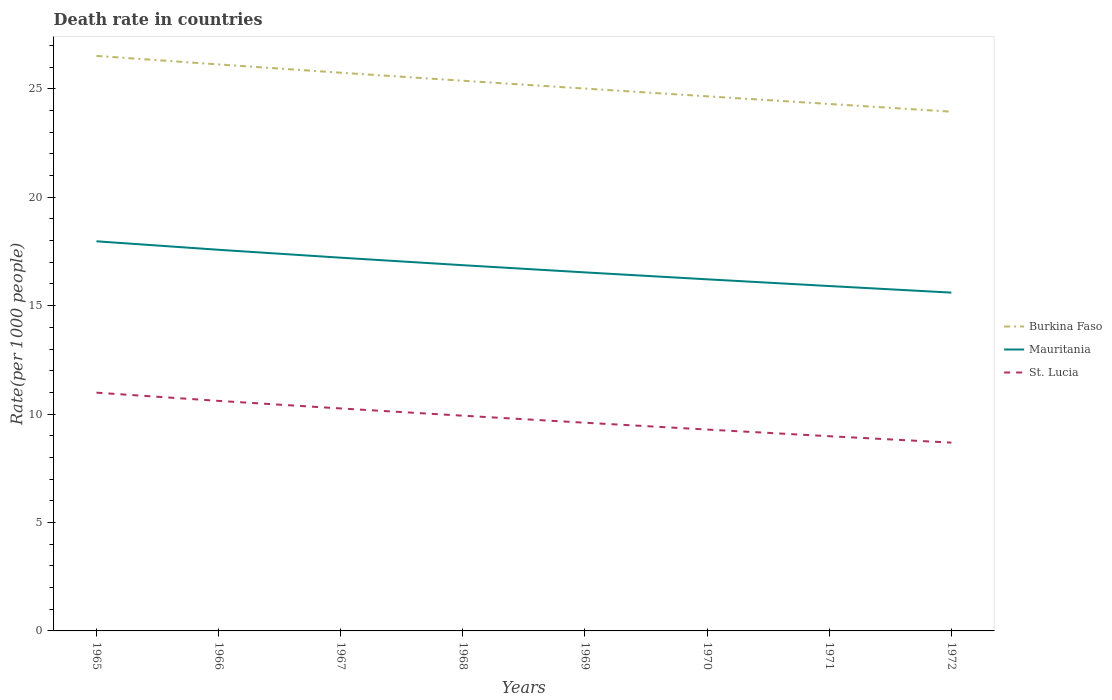Does the line corresponding to Burkina Faso intersect with the line corresponding to St. Lucia?
Keep it short and to the point. No. Across all years, what is the maximum death rate in Mauritania?
Provide a short and direct response. 15.6. In which year was the death rate in St. Lucia maximum?
Your answer should be compact. 1972. What is the total death rate in St. Lucia in the graph?
Offer a terse response. 0.32. What is the difference between the highest and the second highest death rate in Burkina Faso?
Your answer should be compact. 2.57. What is the difference between the highest and the lowest death rate in St. Lucia?
Make the answer very short. 4. Is the death rate in Burkina Faso strictly greater than the death rate in Mauritania over the years?
Offer a terse response. No. How many lines are there?
Your response must be concise. 3. Are the values on the major ticks of Y-axis written in scientific E-notation?
Provide a short and direct response. No. Does the graph contain any zero values?
Your answer should be compact. No. Where does the legend appear in the graph?
Offer a very short reply. Center right. What is the title of the graph?
Offer a very short reply. Death rate in countries. Does "Korea (Democratic)" appear as one of the legend labels in the graph?
Your answer should be compact. No. What is the label or title of the X-axis?
Your answer should be very brief. Years. What is the label or title of the Y-axis?
Ensure brevity in your answer.  Rate(per 1000 people). What is the Rate(per 1000 people) of Burkina Faso in 1965?
Offer a terse response. 26.52. What is the Rate(per 1000 people) in Mauritania in 1965?
Make the answer very short. 17.97. What is the Rate(per 1000 people) in St. Lucia in 1965?
Make the answer very short. 10.99. What is the Rate(per 1000 people) of Burkina Faso in 1966?
Ensure brevity in your answer.  26.12. What is the Rate(per 1000 people) of Mauritania in 1966?
Your answer should be very brief. 17.58. What is the Rate(per 1000 people) of St. Lucia in 1966?
Offer a very short reply. 10.61. What is the Rate(per 1000 people) of Burkina Faso in 1967?
Ensure brevity in your answer.  25.74. What is the Rate(per 1000 people) of Mauritania in 1967?
Keep it short and to the point. 17.21. What is the Rate(per 1000 people) of St. Lucia in 1967?
Offer a very short reply. 10.26. What is the Rate(per 1000 people) in Burkina Faso in 1968?
Your answer should be very brief. 25.37. What is the Rate(per 1000 people) of Mauritania in 1968?
Ensure brevity in your answer.  16.86. What is the Rate(per 1000 people) in St. Lucia in 1968?
Offer a terse response. 9.93. What is the Rate(per 1000 people) in Burkina Faso in 1969?
Ensure brevity in your answer.  25.01. What is the Rate(per 1000 people) in Mauritania in 1969?
Make the answer very short. 16.53. What is the Rate(per 1000 people) of St. Lucia in 1969?
Your answer should be very brief. 9.6. What is the Rate(per 1000 people) in Burkina Faso in 1970?
Ensure brevity in your answer.  24.65. What is the Rate(per 1000 people) of Mauritania in 1970?
Give a very brief answer. 16.21. What is the Rate(per 1000 people) in St. Lucia in 1970?
Your answer should be compact. 9.29. What is the Rate(per 1000 people) in Burkina Faso in 1971?
Provide a succinct answer. 24.3. What is the Rate(per 1000 people) of Mauritania in 1971?
Offer a terse response. 15.9. What is the Rate(per 1000 people) of St. Lucia in 1971?
Ensure brevity in your answer.  8.98. What is the Rate(per 1000 people) of Burkina Faso in 1972?
Keep it short and to the point. 23.94. What is the Rate(per 1000 people) in Mauritania in 1972?
Provide a short and direct response. 15.6. What is the Rate(per 1000 people) in St. Lucia in 1972?
Provide a short and direct response. 8.68. Across all years, what is the maximum Rate(per 1000 people) in Burkina Faso?
Your answer should be compact. 26.52. Across all years, what is the maximum Rate(per 1000 people) in Mauritania?
Offer a terse response. 17.97. Across all years, what is the maximum Rate(per 1000 people) in St. Lucia?
Give a very brief answer. 10.99. Across all years, what is the minimum Rate(per 1000 people) of Burkina Faso?
Give a very brief answer. 23.94. Across all years, what is the minimum Rate(per 1000 people) of Mauritania?
Your response must be concise. 15.6. Across all years, what is the minimum Rate(per 1000 people) of St. Lucia?
Provide a short and direct response. 8.68. What is the total Rate(per 1000 people) in Burkina Faso in the graph?
Provide a short and direct response. 201.66. What is the total Rate(per 1000 people) of Mauritania in the graph?
Make the answer very short. 133.87. What is the total Rate(per 1000 people) in St. Lucia in the graph?
Provide a succinct answer. 78.33. What is the difference between the Rate(per 1000 people) in Burkina Faso in 1965 and that in 1966?
Give a very brief answer. 0.39. What is the difference between the Rate(per 1000 people) in Mauritania in 1965 and that in 1966?
Provide a short and direct response. 0.39. What is the difference between the Rate(per 1000 people) in St. Lucia in 1965 and that in 1966?
Offer a very short reply. 0.38. What is the difference between the Rate(per 1000 people) in Burkina Faso in 1965 and that in 1967?
Give a very brief answer. 0.78. What is the difference between the Rate(per 1000 people) in Mauritania in 1965 and that in 1967?
Ensure brevity in your answer.  0.76. What is the difference between the Rate(per 1000 people) of St. Lucia in 1965 and that in 1967?
Make the answer very short. 0.73. What is the difference between the Rate(per 1000 people) in Burkina Faso in 1965 and that in 1968?
Provide a short and direct response. 1.15. What is the difference between the Rate(per 1000 people) of Mauritania in 1965 and that in 1968?
Provide a short and direct response. 1.1. What is the difference between the Rate(per 1000 people) in St. Lucia in 1965 and that in 1968?
Your response must be concise. 1.06. What is the difference between the Rate(per 1000 people) in Burkina Faso in 1965 and that in 1969?
Your response must be concise. 1.51. What is the difference between the Rate(per 1000 people) in Mauritania in 1965 and that in 1969?
Offer a very short reply. 1.43. What is the difference between the Rate(per 1000 people) of St. Lucia in 1965 and that in 1969?
Your answer should be compact. 1.39. What is the difference between the Rate(per 1000 people) in Burkina Faso in 1965 and that in 1970?
Offer a terse response. 1.86. What is the difference between the Rate(per 1000 people) in Mauritania in 1965 and that in 1970?
Provide a short and direct response. 1.75. What is the difference between the Rate(per 1000 people) in St. Lucia in 1965 and that in 1970?
Keep it short and to the point. 1.7. What is the difference between the Rate(per 1000 people) of Burkina Faso in 1965 and that in 1971?
Offer a terse response. 2.22. What is the difference between the Rate(per 1000 people) of Mauritania in 1965 and that in 1971?
Offer a very short reply. 2.06. What is the difference between the Rate(per 1000 people) of St. Lucia in 1965 and that in 1971?
Offer a terse response. 2.01. What is the difference between the Rate(per 1000 people) in Burkina Faso in 1965 and that in 1972?
Keep it short and to the point. 2.57. What is the difference between the Rate(per 1000 people) in Mauritania in 1965 and that in 1972?
Keep it short and to the point. 2.37. What is the difference between the Rate(per 1000 people) of St. Lucia in 1965 and that in 1972?
Provide a short and direct response. 2.3. What is the difference between the Rate(per 1000 people) of Burkina Faso in 1966 and that in 1967?
Your answer should be compact. 0.38. What is the difference between the Rate(per 1000 people) in Mauritania in 1966 and that in 1967?
Ensure brevity in your answer.  0.36. What is the difference between the Rate(per 1000 people) in St. Lucia in 1966 and that in 1967?
Offer a terse response. 0.35. What is the difference between the Rate(per 1000 people) of Burkina Faso in 1966 and that in 1968?
Give a very brief answer. 0.75. What is the difference between the Rate(per 1000 people) of Mauritania in 1966 and that in 1968?
Your answer should be very brief. 0.71. What is the difference between the Rate(per 1000 people) of St. Lucia in 1966 and that in 1968?
Make the answer very short. 0.68. What is the difference between the Rate(per 1000 people) in Burkina Faso in 1966 and that in 1969?
Give a very brief answer. 1.11. What is the difference between the Rate(per 1000 people) in Mauritania in 1966 and that in 1969?
Keep it short and to the point. 1.04. What is the difference between the Rate(per 1000 people) in St. Lucia in 1966 and that in 1969?
Your response must be concise. 1.01. What is the difference between the Rate(per 1000 people) in Burkina Faso in 1966 and that in 1970?
Provide a succinct answer. 1.47. What is the difference between the Rate(per 1000 people) in Mauritania in 1966 and that in 1970?
Make the answer very short. 1.36. What is the difference between the Rate(per 1000 people) of St. Lucia in 1966 and that in 1970?
Give a very brief answer. 1.32. What is the difference between the Rate(per 1000 people) in Burkina Faso in 1966 and that in 1971?
Your answer should be very brief. 1.82. What is the difference between the Rate(per 1000 people) in Mauritania in 1966 and that in 1971?
Your answer should be very brief. 1.67. What is the difference between the Rate(per 1000 people) in St. Lucia in 1966 and that in 1971?
Your answer should be very brief. 1.63. What is the difference between the Rate(per 1000 people) in Burkina Faso in 1966 and that in 1972?
Keep it short and to the point. 2.18. What is the difference between the Rate(per 1000 people) in Mauritania in 1966 and that in 1972?
Keep it short and to the point. 1.98. What is the difference between the Rate(per 1000 people) of St. Lucia in 1966 and that in 1972?
Your response must be concise. 1.93. What is the difference between the Rate(per 1000 people) of Burkina Faso in 1967 and that in 1968?
Give a very brief answer. 0.37. What is the difference between the Rate(per 1000 people) in Mauritania in 1967 and that in 1968?
Your response must be concise. 0.35. What is the difference between the Rate(per 1000 people) of St. Lucia in 1967 and that in 1968?
Give a very brief answer. 0.33. What is the difference between the Rate(per 1000 people) in Burkina Faso in 1967 and that in 1969?
Make the answer very short. 0.73. What is the difference between the Rate(per 1000 people) in Mauritania in 1967 and that in 1969?
Provide a short and direct response. 0.68. What is the difference between the Rate(per 1000 people) of St. Lucia in 1967 and that in 1969?
Offer a terse response. 0.66. What is the difference between the Rate(per 1000 people) of Burkina Faso in 1967 and that in 1970?
Give a very brief answer. 1.09. What is the difference between the Rate(per 1000 people) in Mauritania in 1967 and that in 1970?
Ensure brevity in your answer.  1. What is the difference between the Rate(per 1000 people) in St. Lucia in 1967 and that in 1970?
Your response must be concise. 0.97. What is the difference between the Rate(per 1000 people) of Burkina Faso in 1967 and that in 1971?
Your answer should be very brief. 1.44. What is the difference between the Rate(per 1000 people) of Mauritania in 1967 and that in 1971?
Your answer should be very brief. 1.31. What is the difference between the Rate(per 1000 people) of St. Lucia in 1967 and that in 1971?
Provide a short and direct response. 1.28. What is the difference between the Rate(per 1000 people) in Burkina Faso in 1967 and that in 1972?
Your answer should be very brief. 1.8. What is the difference between the Rate(per 1000 people) in Mauritania in 1967 and that in 1972?
Provide a short and direct response. 1.61. What is the difference between the Rate(per 1000 people) of St. Lucia in 1967 and that in 1972?
Provide a succinct answer. 1.58. What is the difference between the Rate(per 1000 people) in Burkina Faso in 1968 and that in 1969?
Provide a succinct answer. 0.36. What is the difference between the Rate(per 1000 people) in Mauritania in 1968 and that in 1969?
Offer a terse response. 0.33. What is the difference between the Rate(per 1000 people) of St. Lucia in 1968 and that in 1969?
Keep it short and to the point. 0.32. What is the difference between the Rate(per 1000 people) of Burkina Faso in 1968 and that in 1970?
Provide a succinct answer. 0.72. What is the difference between the Rate(per 1000 people) of Mauritania in 1968 and that in 1970?
Keep it short and to the point. 0.65. What is the difference between the Rate(per 1000 people) in St. Lucia in 1968 and that in 1970?
Offer a very short reply. 0.64. What is the difference between the Rate(per 1000 people) of Burkina Faso in 1968 and that in 1971?
Your answer should be compact. 1.07. What is the difference between the Rate(per 1000 people) in Mauritania in 1968 and that in 1971?
Offer a very short reply. 0.96. What is the difference between the Rate(per 1000 people) in St. Lucia in 1968 and that in 1971?
Provide a succinct answer. 0.95. What is the difference between the Rate(per 1000 people) of Burkina Faso in 1968 and that in 1972?
Provide a succinct answer. 1.43. What is the difference between the Rate(per 1000 people) in Mauritania in 1968 and that in 1972?
Offer a very short reply. 1.26. What is the difference between the Rate(per 1000 people) of St. Lucia in 1968 and that in 1972?
Make the answer very short. 1.24. What is the difference between the Rate(per 1000 people) in Burkina Faso in 1969 and that in 1970?
Offer a terse response. 0.36. What is the difference between the Rate(per 1000 people) of Mauritania in 1969 and that in 1970?
Make the answer very short. 0.32. What is the difference between the Rate(per 1000 people) of St. Lucia in 1969 and that in 1970?
Offer a very short reply. 0.32. What is the difference between the Rate(per 1000 people) of Burkina Faso in 1969 and that in 1971?
Make the answer very short. 0.71. What is the difference between the Rate(per 1000 people) of Mauritania in 1969 and that in 1971?
Make the answer very short. 0.63. What is the difference between the Rate(per 1000 people) in St. Lucia in 1969 and that in 1971?
Your answer should be very brief. 0.62. What is the difference between the Rate(per 1000 people) of Burkina Faso in 1969 and that in 1972?
Keep it short and to the point. 1.06. What is the difference between the Rate(per 1000 people) in Mauritania in 1969 and that in 1972?
Provide a short and direct response. 0.93. What is the difference between the Rate(per 1000 people) of St. Lucia in 1969 and that in 1972?
Make the answer very short. 0.92. What is the difference between the Rate(per 1000 people) of Burkina Faso in 1970 and that in 1971?
Your answer should be very brief. 0.35. What is the difference between the Rate(per 1000 people) of Mauritania in 1970 and that in 1971?
Make the answer very short. 0.31. What is the difference between the Rate(per 1000 people) of St. Lucia in 1970 and that in 1971?
Provide a succinct answer. 0.31. What is the difference between the Rate(per 1000 people) in Burkina Faso in 1970 and that in 1972?
Ensure brevity in your answer.  0.71. What is the difference between the Rate(per 1000 people) of Mauritania in 1970 and that in 1972?
Provide a short and direct response. 0.61. What is the difference between the Rate(per 1000 people) of St. Lucia in 1970 and that in 1972?
Make the answer very short. 0.6. What is the difference between the Rate(per 1000 people) of Burkina Faso in 1971 and that in 1972?
Your response must be concise. 0.36. What is the difference between the Rate(per 1000 people) in Mauritania in 1971 and that in 1972?
Offer a very short reply. 0.3. What is the difference between the Rate(per 1000 people) of St. Lucia in 1971 and that in 1972?
Your answer should be very brief. 0.3. What is the difference between the Rate(per 1000 people) in Burkina Faso in 1965 and the Rate(per 1000 people) in Mauritania in 1966?
Give a very brief answer. 8.94. What is the difference between the Rate(per 1000 people) in Burkina Faso in 1965 and the Rate(per 1000 people) in St. Lucia in 1966?
Provide a succinct answer. 15.91. What is the difference between the Rate(per 1000 people) of Mauritania in 1965 and the Rate(per 1000 people) of St. Lucia in 1966?
Ensure brevity in your answer.  7.36. What is the difference between the Rate(per 1000 people) in Burkina Faso in 1965 and the Rate(per 1000 people) in Mauritania in 1967?
Make the answer very short. 9.3. What is the difference between the Rate(per 1000 people) of Burkina Faso in 1965 and the Rate(per 1000 people) of St. Lucia in 1967?
Keep it short and to the point. 16.26. What is the difference between the Rate(per 1000 people) in Mauritania in 1965 and the Rate(per 1000 people) in St. Lucia in 1967?
Give a very brief answer. 7.71. What is the difference between the Rate(per 1000 people) of Burkina Faso in 1965 and the Rate(per 1000 people) of Mauritania in 1968?
Your answer should be very brief. 9.65. What is the difference between the Rate(per 1000 people) of Burkina Faso in 1965 and the Rate(per 1000 people) of St. Lucia in 1968?
Your answer should be very brief. 16.59. What is the difference between the Rate(per 1000 people) of Mauritania in 1965 and the Rate(per 1000 people) of St. Lucia in 1968?
Ensure brevity in your answer.  8.04. What is the difference between the Rate(per 1000 people) in Burkina Faso in 1965 and the Rate(per 1000 people) in Mauritania in 1969?
Provide a short and direct response. 9.98. What is the difference between the Rate(per 1000 people) of Burkina Faso in 1965 and the Rate(per 1000 people) of St. Lucia in 1969?
Offer a very short reply. 16.91. What is the difference between the Rate(per 1000 people) in Mauritania in 1965 and the Rate(per 1000 people) in St. Lucia in 1969?
Offer a terse response. 8.37. What is the difference between the Rate(per 1000 people) of Burkina Faso in 1965 and the Rate(per 1000 people) of Mauritania in 1970?
Your answer should be compact. 10.3. What is the difference between the Rate(per 1000 people) of Burkina Faso in 1965 and the Rate(per 1000 people) of St. Lucia in 1970?
Your answer should be very brief. 17.23. What is the difference between the Rate(per 1000 people) of Mauritania in 1965 and the Rate(per 1000 people) of St. Lucia in 1970?
Offer a very short reply. 8.68. What is the difference between the Rate(per 1000 people) of Burkina Faso in 1965 and the Rate(per 1000 people) of Mauritania in 1971?
Provide a short and direct response. 10.61. What is the difference between the Rate(per 1000 people) of Burkina Faso in 1965 and the Rate(per 1000 people) of St. Lucia in 1971?
Give a very brief answer. 17.54. What is the difference between the Rate(per 1000 people) of Mauritania in 1965 and the Rate(per 1000 people) of St. Lucia in 1971?
Make the answer very short. 8.99. What is the difference between the Rate(per 1000 people) in Burkina Faso in 1965 and the Rate(per 1000 people) in Mauritania in 1972?
Provide a short and direct response. 10.91. What is the difference between the Rate(per 1000 people) in Burkina Faso in 1965 and the Rate(per 1000 people) in St. Lucia in 1972?
Provide a succinct answer. 17.83. What is the difference between the Rate(per 1000 people) in Mauritania in 1965 and the Rate(per 1000 people) in St. Lucia in 1972?
Your answer should be compact. 9.28. What is the difference between the Rate(per 1000 people) of Burkina Faso in 1966 and the Rate(per 1000 people) of Mauritania in 1967?
Offer a very short reply. 8.91. What is the difference between the Rate(per 1000 people) in Burkina Faso in 1966 and the Rate(per 1000 people) in St. Lucia in 1967?
Provide a succinct answer. 15.86. What is the difference between the Rate(per 1000 people) in Mauritania in 1966 and the Rate(per 1000 people) in St. Lucia in 1967?
Give a very brief answer. 7.32. What is the difference between the Rate(per 1000 people) of Burkina Faso in 1966 and the Rate(per 1000 people) of Mauritania in 1968?
Give a very brief answer. 9.26. What is the difference between the Rate(per 1000 people) of Burkina Faso in 1966 and the Rate(per 1000 people) of St. Lucia in 1968?
Make the answer very short. 16.2. What is the difference between the Rate(per 1000 people) in Mauritania in 1966 and the Rate(per 1000 people) in St. Lucia in 1968?
Keep it short and to the point. 7.65. What is the difference between the Rate(per 1000 people) in Burkina Faso in 1966 and the Rate(per 1000 people) in Mauritania in 1969?
Keep it short and to the point. 9.59. What is the difference between the Rate(per 1000 people) of Burkina Faso in 1966 and the Rate(per 1000 people) of St. Lucia in 1969?
Offer a very short reply. 16.52. What is the difference between the Rate(per 1000 people) in Mauritania in 1966 and the Rate(per 1000 people) in St. Lucia in 1969?
Ensure brevity in your answer.  7.97. What is the difference between the Rate(per 1000 people) in Burkina Faso in 1966 and the Rate(per 1000 people) in Mauritania in 1970?
Your answer should be very brief. 9.91. What is the difference between the Rate(per 1000 people) in Burkina Faso in 1966 and the Rate(per 1000 people) in St. Lucia in 1970?
Your answer should be very brief. 16.84. What is the difference between the Rate(per 1000 people) of Mauritania in 1966 and the Rate(per 1000 people) of St. Lucia in 1970?
Your answer should be compact. 8.29. What is the difference between the Rate(per 1000 people) of Burkina Faso in 1966 and the Rate(per 1000 people) of Mauritania in 1971?
Offer a terse response. 10.22. What is the difference between the Rate(per 1000 people) in Burkina Faso in 1966 and the Rate(per 1000 people) in St. Lucia in 1971?
Offer a terse response. 17.14. What is the difference between the Rate(per 1000 people) in Mauritania in 1966 and the Rate(per 1000 people) in St. Lucia in 1971?
Provide a succinct answer. 8.6. What is the difference between the Rate(per 1000 people) of Burkina Faso in 1966 and the Rate(per 1000 people) of Mauritania in 1972?
Provide a short and direct response. 10.52. What is the difference between the Rate(per 1000 people) of Burkina Faso in 1966 and the Rate(per 1000 people) of St. Lucia in 1972?
Offer a very short reply. 17.44. What is the difference between the Rate(per 1000 people) of Mauritania in 1966 and the Rate(per 1000 people) of St. Lucia in 1972?
Keep it short and to the point. 8.89. What is the difference between the Rate(per 1000 people) in Burkina Faso in 1967 and the Rate(per 1000 people) in Mauritania in 1968?
Your answer should be compact. 8.88. What is the difference between the Rate(per 1000 people) in Burkina Faso in 1967 and the Rate(per 1000 people) in St. Lucia in 1968?
Your answer should be very brief. 15.82. What is the difference between the Rate(per 1000 people) in Mauritania in 1967 and the Rate(per 1000 people) in St. Lucia in 1968?
Make the answer very short. 7.29. What is the difference between the Rate(per 1000 people) in Burkina Faso in 1967 and the Rate(per 1000 people) in Mauritania in 1969?
Provide a short and direct response. 9.21. What is the difference between the Rate(per 1000 people) of Burkina Faso in 1967 and the Rate(per 1000 people) of St. Lucia in 1969?
Your answer should be very brief. 16.14. What is the difference between the Rate(per 1000 people) in Mauritania in 1967 and the Rate(per 1000 people) in St. Lucia in 1969?
Offer a very short reply. 7.61. What is the difference between the Rate(per 1000 people) in Burkina Faso in 1967 and the Rate(per 1000 people) in Mauritania in 1970?
Provide a succinct answer. 9.53. What is the difference between the Rate(per 1000 people) in Burkina Faso in 1967 and the Rate(per 1000 people) in St. Lucia in 1970?
Your answer should be compact. 16.45. What is the difference between the Rate(per 1000 people) of Mauritania in 1967 and the Rate(per 1000 people) of St. Lucia in 1970?
Your answer should be compact. 7.92. What is the difference between the Rate(per 1000 people) of Burkina Faso in 1967 and the Rate(per 1000 people) of Mauritania in 1971?
Provide a succinct answer. 9.84. What is the difference between the Rate(per 1000 people) in Burkina Faso in 1967 and the Rate(per 1000 people) in St. Lucia in 1971?
Provide a succinct answer. 16.76. What is the difference between the Rate(per 1000 people) in Mauritania in 1967 and the Rate(per 1000 people) in St. Lucia in 1971?
Your answer should be compact. 8.23. What is the difference between the Rate(per 1000 people) of Burkina Faso in 1967 and the Rate(per 1000 people) of Mauritania in 1972?
Your answer should be very brief. 10.14. What is the difference between the Rate(per 1000 people) in Burkina Faso in 1967 and the Rate(per 1000 people) in St. Lucia in 1972?
Keep it short and to the point. 17.06. What is the difference between the Rate(per 1000 people) of Mauritania in 1967 and the Rate(per 1000 people) of St. Lucia in 1972?
Give a very brief answer. 8.53. What is the difference between the Rate(per 1000 people) of Burkina Faso in 1968 and the Rate(per 1000 people) of Mauritania in 1969?
Keep it short and to the point. 8.84. What is the difference between the Rate(per 1000 people) of Burkina Faso in 1968 and the Rate(per 1000 people) of St. Lucia in 1969?
Your response must be concise. 15.77. What is the difference between the Rate(per 1000 people) in Mauritania in 1968 and the Rate(per 1000 people) in St. Lucia in 1969?
Your response must be concise. 7.26. What is the difference between the Rate(per 1000 people) of Burkina Faso in 1968 and the Rate(per 1000 people) of Mauritania in 1970?
Ensure brevity in your answer.  9.16. What is the difference between the Rate(per 1000 people) of Burkina Faso in 1968 and the Rate(per 1000 people) of St. Lucia in 1970?
Keep it short and to the point. 16.09. What is the difference between the Rate(per 1000 people) of Mauritania in 1968 and the Rate(per 1000 people) of St. Lucia in 1970?
Your answer should be very brief. 7.58. What is the difference between the Rate(per 1000 people) of Burkina Faso in 1968 and the Rate(per 1000 people) of Mauritania in 1971?
Your answer should be very brief. 9.47. What is the difference between the Rate(per 1000 people) in Burkina Faso in 1968 and the Rate(per 1000 people) in St. Lucia in 1971?
Keep it short and to the point. 16.39. What is the difference between the Rate(per 1000 people) in Mauritania in 1968 and the Rate(per 1000 people) in St. Lucia in 1971?
Your answer should be compact. 7.89. What is the difference between the Rate(per 1000 people) of Burkina Faso in 1968 and the Rate(per 1000 people) of Mauritania in 1972?
Offer a terse response. 9.77. What is the difference between the Rate(per 1000 people) in Burkina Faso in 1968 and the Rate(per 1000 people) in St. Lucia in 1972?
Provide a succinct answer. 16.69. What is the difference between the Rate(per 1000 people) in Mauritania in 1968 and the Rate(per 1000 people) in St. Lucia in 1972?
Your answer should be compact. 8.18. What is the difference between the Rate(per 1000 people) in Burkina Faso in 1969 and the Rate(per 1000 people) in Mauritania in 1970?
Your response must be concise. 8.79. What is the difference between the Rate(per 1000 people) in Burkina Faso in 1969 and the Rate(per 1000 people) in St. Lucia in 1970?
Offer a terse response. 15.72. What is the difference between the Rate(per 1000 people) in Mauritania in 1969 and the Rate(per 1000 people) in St. Lucia in 1970?
Offer a terse response. 7.25. What is the difference between the Rate(per 1000 people) in Burkina Faso in 1969 and the Rate(per 1000 people) in Mauritania in 1971?
Offer a very short reply. 9.11. What is the difference between the Rate(per 1000 people) of Burkina Faso in 1969 and the Rate(per 1000 people) of St. Lucia in 1971?
Make the answer very short. 16.03. What is the difference between the Rate(per 1000 people) in Mauritania in 1969 and the Rate(per 1000 people) in St. Lucia in 1971?
Give a very brief answer. 7.55. What is the difference between the Rate(per 1000 people) in Burkina Faso in 1969 and the Rate(per 1000 people) in Mauritania in 1972?
Give a very brief answer. 9.41. What is the difference between the Rate(per 1000 people) in Burkina Faso in 1969 and the Rate(per 1000 people) in St. Lucia in 1972?
Make the answer very short. 16.33. What is the difference between the Rate(per 1000 people) of Mauritania in 1969 and the Rate(per 1000 people) of St. Lucia in 1972?
Provide a short and direct response. 7.85. What is the difference between the Rate(per 1000 people) in Burkina Faso in 1970 and the Rate(per 1000 people) in Mauritania in 1971?
Your answer should be compact. 8.75. What is the difference between the Rate(per 1000 people) of Burkina Faso in 1970 and the Rate(per 1000 people) of St. Lucia in 1971?
Make the answer very short. 15.67. What is the difference between the Rate(per 1000 people) in Mauritania in 1970 and the Rate(per 1000 people) in St. Lucia in 1971?
Give a very brief answer. 7.24. What is the difference between the Rate(per 1000 people) of Burkina Faso in 1970 and the Rate(per 1000 people) of Mauritania in 1972?
Provide a succinct answer. 9.05. What is the difference between the Rate(per 1000 people) in Burkina Faso in 1970 and the Rate(per 1000 people) in St. Lucia in 1972?
Your answer should be very brief. 15.97. What is the difference between the Rate(per 1000 people) of Mauritania in 1970 and the Rate(per 1000 people) of St. Lucia in 1972?
Give a very brief answer. 7.53. What is the difference between the Rate(per 1000 people) in Burkina Faso in 1971 and the Rate(per 1000 people) in Mauritania in 1972?
Keep it short and to the point. 8.7. What is the difference between the Rate(per 1000 people) of Burkina Faso in 1971 and the Rate(per 1000 people) of St. Lucia in 1972?
Your response must be concise. 15.62. What is the difference between the Rate(per 1000 people) of Mauritania in 1971 and the Rate(per 1000 people) of St. Lucia in 1972?
Offer a very short reply. 7.22. What is the average Rate(per 1000 people) in Burkina Faso per year?
Offer a very short reply. 25.21. What is the average Rate(per 1000 people) in Mauritania per year?
Make the answer very short. 16.73. What is the average Rate(per 1000 people) in St. Lucia per year?
Offer a terse response. 9.79. In the year 1965, what is the difference between the Rate(per 1000 people) of Burkina Faso and Rate(per 1000 people) of Mauritania?
Give a very brief answer. 8.55. In the year 1965, what is the difference between the Rate(per 1000 people) of Burkina Faso and Rate(per 1000 people) of St. Lucia?
Provide a short and direct response. 15.53. In the year 1965, what is the difference between the Rate(per 1000 people) in Mauritania and Rate(per 1000 people) in St. Lucia?
Give a very brief answer. 6.98. In the year 1966, what is the difference between the Rate(per 1000 people) in Burkina Faso and Rate(per 1000 people) in Mauritania?
Provide a succinct answer. 8.55. In the year 1966, what is the difference between the Rate(per 1000 people) in Burkina Faso and Rate(per 1000 people) in St. Lucia?
Your answer should be very brief. 15.52. In the year 1966, what is the difference between the Rate(per 1000 people) in Mauritania and Rate(per 1000 people) in St. Lucia?
Provide a succinct answer. 6.97. In the year 1967, what is the difference between the Rate(per 1000 people) in Burkina Faso and Rate(per 1000 people) in Mauritania?
Provide a succinct answer. 8.53. In the year 1967, what is the difference between the Rate(per 1000 people) of Burkina Faso and Rate(per 1000 people) of St. Lucia?
Offer a terse response. 15.48. In the year 1967, what is the difference between the Rate(per 1000 people) in Mauritania and Rate(per 1000 people) in St. Lucia?
Offer a very short reply. 6.95. In the year 1968, what is the difference between the Rate(per 1000 people) of Burkina Faso and Rate(per 1000 people) of Mauritania?
Offer a very short reply. 8.51. In the year 1968, what is the difference between the Rate(per 1000 people) in Burkina Faso and Rate(per 1000 people) in St. Lucia?
Ensure brevity in your answer.  15.45. In the year 1968, what is the difference between the Rate(per 1000 people) in Mauritania and Rate(per 1000 people) in St. Lucia?
Provide a short and direct response. 6.94. In the year 1969, what is the difference between the Rate(per 1000 people) in Burkina Faso and Rate(per 1000 people) in Mauritania?
Offer a very short reply. 8.48. In the year 1969, what is the difference between the Rate(per 1000 people) of Burkina Faso and Rate(per 1000 people) of St. Lucia?
Offer a terse response. 15.41. In the year 1969, what is the difference between the Rate(per 1000 people) of Mauritania and Rate(per 1000 people) of St. Lucia?
Your answer should be very brief. 6.93. In the year 1970, what is the difference between the Rate(per 1000 people) in Burkina Faso and Rate(per 1000 people) in Mauritania?
Offer a terse response. 8.44. In the year 1970, what is the difference between the Rate(per 1000 people) of Burkina Faso and Rate(per 1000 people) of St. Lucia?
Make the answer very short. 15.37. In the year 1970, what is the difference between the Rate(per 1000 people) in Mauritania and Rate(per 1000 people) in St. Lucia?
Provide a succinct answer. 6.93. In the year 1971, what is the difference between the Rate(per 1000 people) of Burkina Faso and Rate(per 1000 people) of Mauritania?
Give a very brief answer. 8.4. In the year 1971, what is the difference between the Rate(per 1000 people) in Burkina Faso and Rate(per 1000 people) in St. Lucia?
Make the answer very short. 15.32. In the year 1971, what is the difference between the Rate(per 1000 people) of Mauritania and Rate(per 1000 people) of St. Lucia?
Your response must be concise. 6.92. In the year 1972, what is the difference between the Rate(per 1000 people) in Burkina Faso and Rate(per 1000 people) in Mauritania?
Keep it short and to the point. 8.34. In the year 1972, what is the difference between the Rate(per 1000 people) of Burkina Faso and Rate(per 1000 people) of St. Lucia?
Provide a succinct answer. 15.26. In the year 1972, what is the difference between the Rate(per 1000 people) in Mauritania and Rate(per 1000 people) in St. Lucia?
Your response must be concise. 6.92. What is the ratio of the Rate(per 1000 people) of Mauritania in 1965 to that in 1966?
Your answer should be compact. 1.02. What is the ratio of the Rate(per 1000 people) of St. Lucia in 1965 to that in 1966?
Give a very brief answer. 1.04. What is the ratio of the Rate(per 1000 people) in Burkina Faso in 1965 to that in 1967?
Your answer should be compact. 1.03. What is the ratio of the Rate(per 1000 people) of Mauritania in 1965 to that in 1967?
Your answer should be very brief. 1.04. What is the ratio of the Rate(per 1000 people) in St. Lucia in 1965 to that in 1967?
Ensure brevity in your answer.  1.07. What is the ratio of the Rate(per 1000 people) of Burkina Faso in 1965 to that in 1968?
Your answer should be very brief. 1.05. What is the ratio of the Rate(per 1000 people) of Mauritania in 1965 to that in 1968?
Offer a very short reply. 1.07. What is the ratio of the Rate(per 1000 people) of St. Lucia in 1965 to that in 1968?
Your response must be concise. 1.11. What is the ratio of the Rate(per 1000 people) of Burkina Faso in 1965 to that in 1969?
Your answer should be compact. 1.06. What is the ratio of the Rate(per 1000 people) in Mauritania in 1965 to that in 1969?
Give a very brief answer. 1.09. What is the ratio of the Rate(per 1000 people) in St. Lucia in 1965 to that in 1969?
Give a very brief answer. 1.14. What is the ratio of the Rate(per 1000 people) of Burkina Faso in 1965 to that in 1970?
Give a very brief answer. 1.08. What is the ratio of the Rate(per 1000 people) in Mauritania in 1965 to that in 1970?
Give a very brief answer. 1.11. What is the ratio of the Rate(per 1000 people) in St. Lucia in 1965 to that in 1970?
Provide a succinct answer. 1.18. What is the ratio of the Rate(per 1000 people) of Burkina Faso in 1965 to that in 1971?
Your response must be concise. 1.09. What is the ratio of the Rate(per 1000 people) of Mauritania in 1965 to that in 1971?
Ensure brevity in your answer.  1.13. What is the ratio of the Rate(per 1000 people) of St. Lucia in 1965 to that in 1971?
Give a very brief answer. 1.22. What is the ratio of the Rate(per 1000 people) in Burkina Faso in 1965 to that in 1972?
Ensure brevity in your answer.  1.11. What is the ratio of the Rate(per 1000 people) in Mauritania in 1965 to that in 1972?
Provide a succinct answer. 1.15. What is the ratio of the Rate(per 1000 people) of St. Lucia in 1965 to that in 1972?
Your answer should be very brief. 1.27. What is the ratio of the Rate(per 1000 people) in Burkina Faso in 1966 to that in 1967?
Keep it short and to the point. 1.01. What is the ratio of the Rate(per 1000 people) of Mauritania in 1966 to that in 1967?
Offer a very short reply. 1.02. What is the ratio of the Rate(per 1000 people) in St. Lucia in 1966 to that in 1967?
Your answer should be very brief. 1.03. What is the ratio of the Rate(per 1000 people) in Burkina Faso in 1966 to that in 1968?
Give a very brief answer. 1.03. What is the ratio of the Rate(per 1000 people) in Mauritania in 1966 to that in 1968?
Give a very brief answer. 1.04. What is the ratio of the Rate(per 1000 people) of St. Lucia in 1966 to that in 1968?
Provide a succinct answer. 1.07. What is the ratio of the Rate(per 1000 people) in Burkina Faso in 1966 to that in 1969?
Ensure brevity in your answer.  1.04. What is the ratio of the Rate(per 1000 people) of Mauritania in 1966 to that in 1969?
Keep it short and to the point. 1.06. What is the ratio of the Rate(per 1000 people) of St. Lucia in 1966 to that in 1969?
Offer a terse response. 1.1. What is the ratio of the Rate(per 1000 people) in Burkina Faso in 1966 to that in 1970?
Ensure brevity in your answer.  1.06. What is the ratio of the Rate(per 1000 people) in Mauritania in 1966 to that in 1970?
Your answer should be very brief. 1.08. What is the ratio of the Rate(per 1000 people) of St. Lucia in 1966 to that in 1970?
Offer a very short reply. 1.14. What is the ratio of the Rate(per 1000 people) of Burkina Faso in 1966 to that in 1971?
Ensure brevity in your answer.  1.07. What is the ratio of the Rate(per 1000 people) in Mauritania in 1966 to that in 1971?
Your answer should be compact. 1.11. What is the ratio of the Rate(per 1000 people) of St. Lucia in 1966 to that in 1971?
Provide a short and direct response. 1.18. What is the ratio of the Rate(per 1000 people) in Burkina Faso in 1966 to that in 1972?
Ensure brevity in your answer.  1.09. What is the ratio of the Rate(per 1000 people) of Mauritania in 1966 to that in 1972?
Ensure brevity in your answer.  1.13. What is the ratio of the Rate(per 1000 people) in St. Lucia in 1966 to that in 1972?
Provide a succinct answer. 1.22. What is the ratio of the Rate(per 1000 people) of Burkina Faso in 1967 to that in 1968?
Offer a terse response. 1.01. What is the ratio of the Rate(per 1000 people) of Mauritania in 1967 to that in 1968?
Make the answer very short. 1.02. What is the ratio of the Rate(per 1000 people) of St. Lucia in 1967 to that in 1968?
Ensure brevity in your answer.  1.03. What is the ratio of the Rate(per 1000 people) of Burkina Faso in 1967 to that in 1969?
Offer a terse response. 1.03. What is the ratio of the Rate(per 1000 people) of Mauritania in 1967 to that in 1969?
Provide a short and direct response. 1.04. What is the ratio of the Rate(per 1000 people) in St. Lucia in 1967 to that in 1969?
Provide a short and direct response. 1.07. What is the ratio of the Rate(per 1000 people) of Burkina Faso in 1967 to that in 1970?
Ensure brevity in your answer.  1.04. What is the ratio of the Rate(per 1000 people) of Mauritania in 1967 to that in 1970?
Your answer should be very brief. 1.06. What is the ratio of the Rate(per 1000 people) in St. Lucia in 1967 to that in 1970?
Ensure brevity in your answer.  1.1. What is the ratio of the Rate(per 1000 people) in Burkina Faso in 1967 to that in 1971?
Provide a short and direct response. 1.06. What is the ratio of the Rate(per 1000 people) in Mauritania in 1967 to that in 1971?
Provide a short and direct response. 1.08. What is the ratio of the Rate(per 1000 people) of St. Lucia in 1967 to that in 1971?
Keep it short and to the point. 1.14. What is the ratio of the Rate(per 1000 people) in Burkina Faso in 1967 to that in 1972?
Your response must be concise. 1.08. What is the ratio of the Rate(per 1000 people) in Mauritania in 1967 to that in 1972?
Give a very brief answer. 1.1. What is the ratio of the Rate(per 1000 people) in St. Lucia in 1967 to that in 1972?
Your response must be concise. 1.18. What is the ratio of the Rate(per 1000 people) of Burkina Faso in 1968 to that in 1969?
Give a very brief answer. 1.01. What is the ratio of the Rate(per 1000 people) in Mauritania in 1968 to that in 1969?
Your answer should be very brief. 1.02. What is the ratio of the Rate(per 1000 people) in St. Lucia in 1968 to that in 1969?
Offer a terse response. 1.03. What is the ratio of the Rate(per 1000 people) in Burkina Faso in 1968 to that in 1970?
Your answer should be very brief. 1.03. What is the ratio of the Rate(per 1000 people) of Mauritania in 1968 to that in 1970?
Offer a very short reply. 1.04. What is the ratio of the Rate(per 1000 people) of St. Lucia in 1968 to that in 1970?
Provide a succinct answer. 1.07. What is the ratio of the Rate(per 1000 people) of Burkina Faso in 1968 to that in 1971?
Keep it short and to the point. 1.04. What is the ratio of the Rate(per 1000 people) in Mauritania in 1968 to that in 1971?
Give a very brief answer. 1.06. What is the ratio of the Rate(per 1000 people) of St. Lucia in 1968 to that in 1971?
Make the answer very short. 1.11. What is the ratio of the Rate(per 1000 people) of Burkina Faso in 1968 to that in 1972?
Keep it short and to the point. 1.06. What is the ratio of the Rate(per 1000 people) in Mauritania in 1968 to that in 1972?
Provide a succinct answer. 1.08. What is the ratio of the Rate(per 1000 people) in St. Lucia in 1968 to that in 1972?
Offer a terse response. 1.14. What is the ratio of the Rate(per 1000 people) in Burkina Faso in 1969 to that in 1970?
Your response must be concise. 1.01. What is the ratio of the Rate(per 1000 people) in Mauritania in 1969 to that in 1970?
Your answer should be very brief. 1.02. What is the ratio of the Rate(per 1000 people) of St. Lucia in 1969 to that in 1970?
Your answer should be very brief. 1.03. What is the ratio of the Rate(per 1000 people) of Burkina Faso in 1969 to that in 1971?
Offer a very short reply. 1.03. What is the ratio of the Rate(per 1000 people) of Mauritania in 1969 to that in 1971?
Keep it short and to the point. 1.04. What is the ratio of the Rate(per 1000 people) of St. Lucia in 1969 to that in 1971?
Offer a very short reply. 1.07. What is the ratio of the Rate(per 1000 people) of Burkina Faso in 1969 to that in 1972?
Your answer should be very brief. 1.04. What is the ratio of the Rate(per 1000 people) in Mauritania in 1969 to that in 1972?
Your response must be concise. 1.06. What is the ratio of the Rate(per 1000 people) in St. Lucia in 1969 to that in 1972?
Provide a short and direct response. 1.11. What is the ratio of the Rate(per 1000 people) of Burkina Faso in 1970 to that in 1971?
Your answer should be compact. 1.01. What is the ratio of the Rate(per 1000 people) in Mauritania in 1970 to that in 1971?
Offer a very short reply. 1.02. What is the ratio of the Rate(per 1000 people) in St. Lucia in 1970 to that in 1971?
Ensure brevity in your answer.  1.03. What is the ratio of the Rate(per 1000 people) in Burkina Faso in 1970 to that in 1972?
Your response must be concise. 1.03. What is the ratio of the Rate(per 1000 people) of Mauritania in 1970 to that in 1972?
Keep it short and to the point. 1.04. What is the ratio of the Rate(per 1000 people) in St. Lucia in 1970 to that in 1972?
Ensure brevity in your answer.  1.07. What is the ratio of the Rate(per 1000 people) of Burkina Faso in 1971 to that in 1972?
Provide a succinct answer. 1.01. What is the ratio of the Rate(per 1000 people) of Mauritania in 1971 to that in 1972?
Your response must be concise. 1.02. What is the ratio of the Rate(per 1000 people) of St. Lucia in 1971 to that in 1972?
Provide a succinct answer. 1.03. What is the difference between the highest and the second highest Rate(per 1000 people) of Burkina Faso?
Your response must be concise. 0.39. What is the difference between the highest and the second highest Rate(per 1000 people) of Mauritania?
Your answer should be very brief. 0.39. What is the difference between the highest and the second highest Rate(per 1000 people) in St. Lucia?
Provide a short and direct response. 0.38. What is the difference between the highest and the lowest Rate(per 1000 people) of Burkina Faso?
Ensure brevity in your answer.  2.57. What is the difference between the highest and the lowest Rate(per 1000 people) of Mauritania?
Your answer should be compact. 2.37. What is the difference between the highest and the lowest Rate(per 1000 people) of St. Lucia?
Make the answer very short. 2.3. 